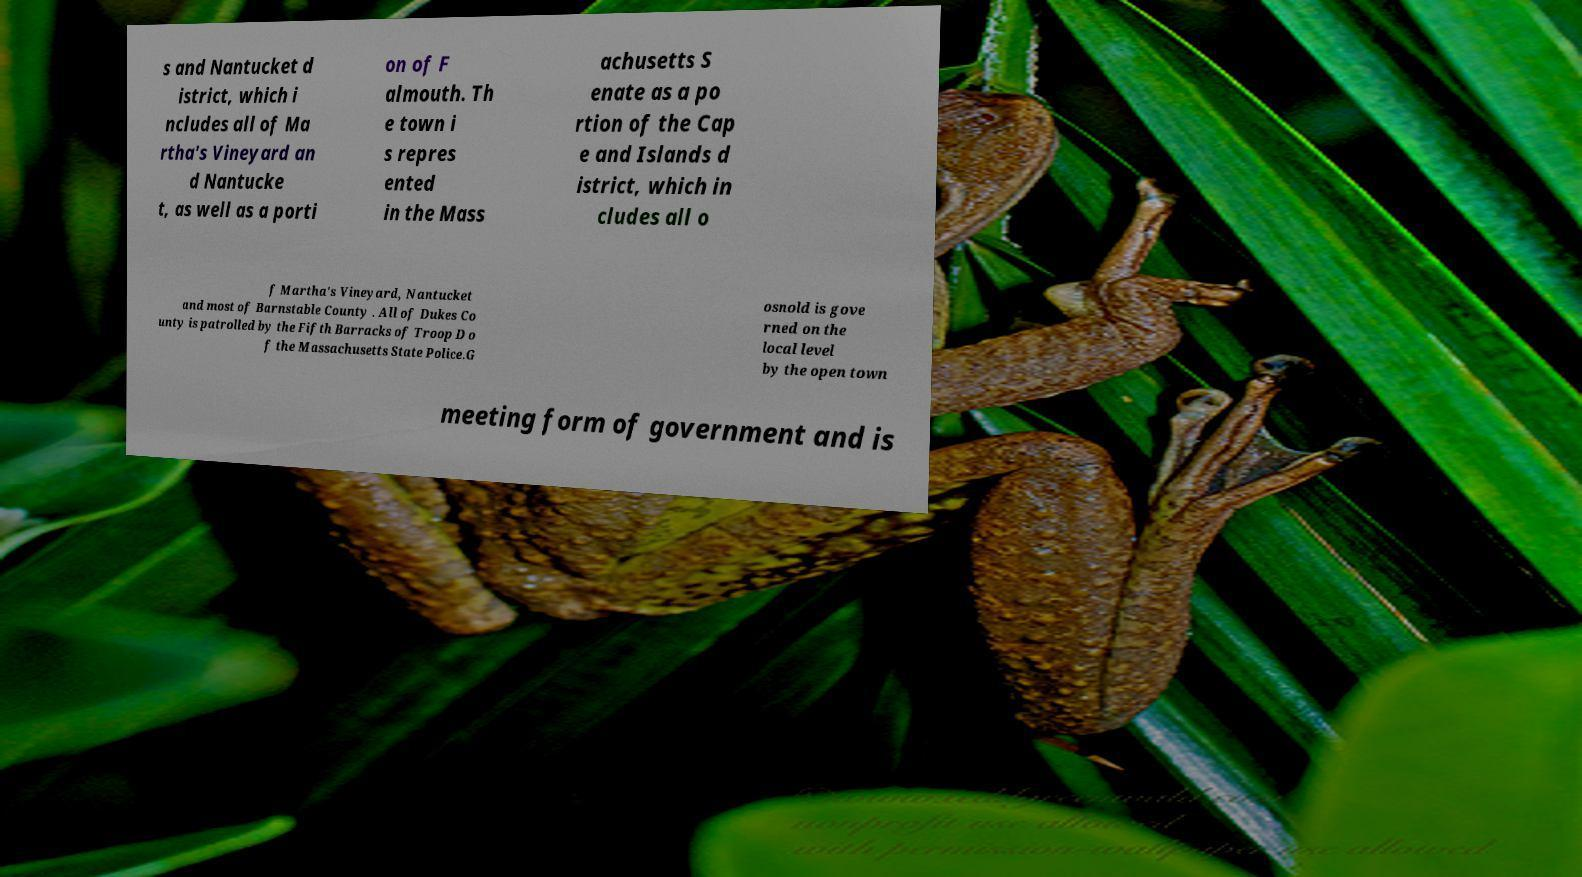There's text embedded in this image that I need extracted. Can you transcribe it verbatim? s and Nantucket d istrict, which i ncludes all of Ma rtha's Vineyard an d Nantucke t, as well as a porti on of F almouth. Th e town i s repres ented in the Mass achusetts S enate as a po rtion of the Cap e and Islands d istrict, which in cludes all o f Martha's Vineyard, Nantucket and most of Barnstable County . All of Dukes Co unty is patrolled by the Fifth Barracks of Troop D o f the Massachusetts State Police.G osnold is gove rned on the local level by the open town meeting form of government and is 